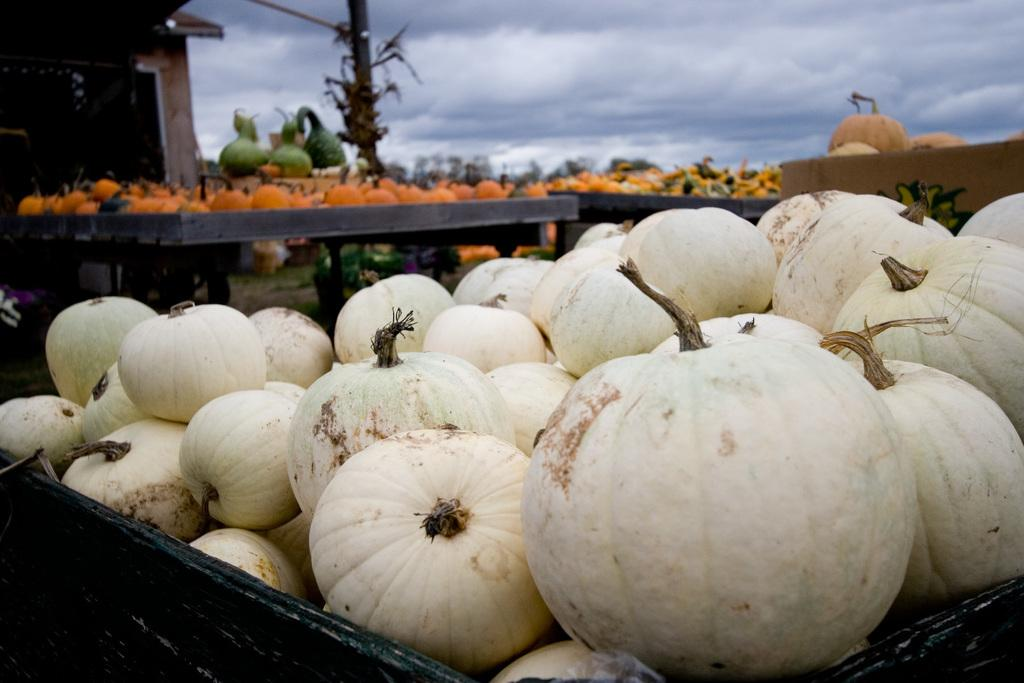What type of objects are present in the image? There are pumpkins in the image. How are the pumpkins arranged in the image? The pumpkins are placed around in the image. How many sisters are present in the image? There are no sisters present in the image; it only features pumpkins. 